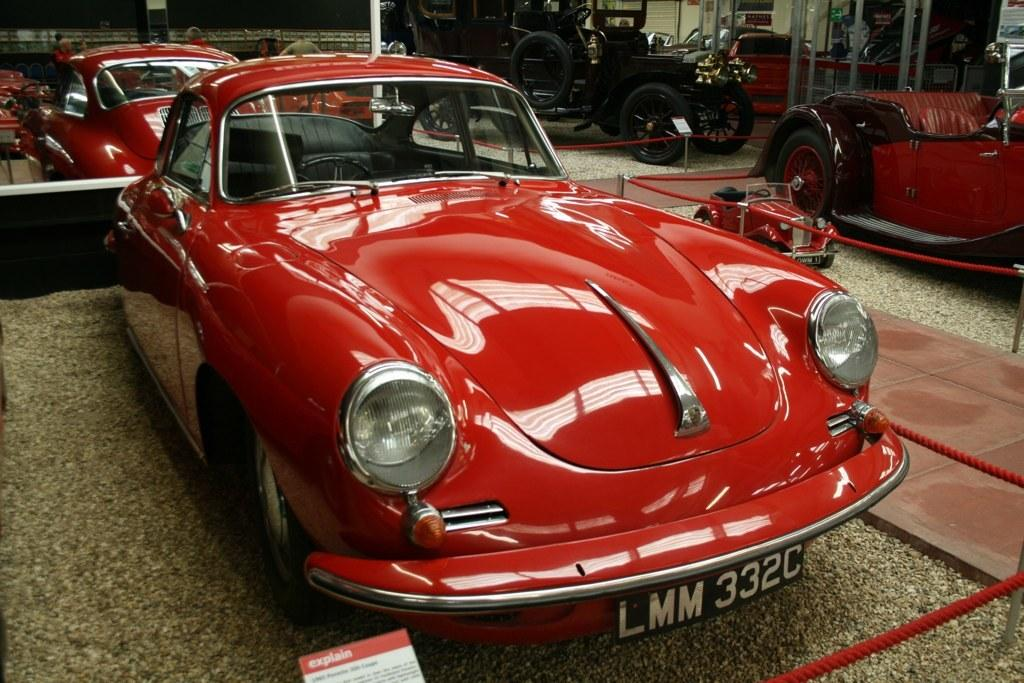What can be seen in the image? There are vehicles in the image. How are the vehicles arranged or organized? The vehicles are surrounded by a rope fence. Are there any additional objects or features in the image? Yes, there are small note boards in the image. What shape is the sugar in the image? There is no sugar present in the image, so it is not possible to determine its shape. 